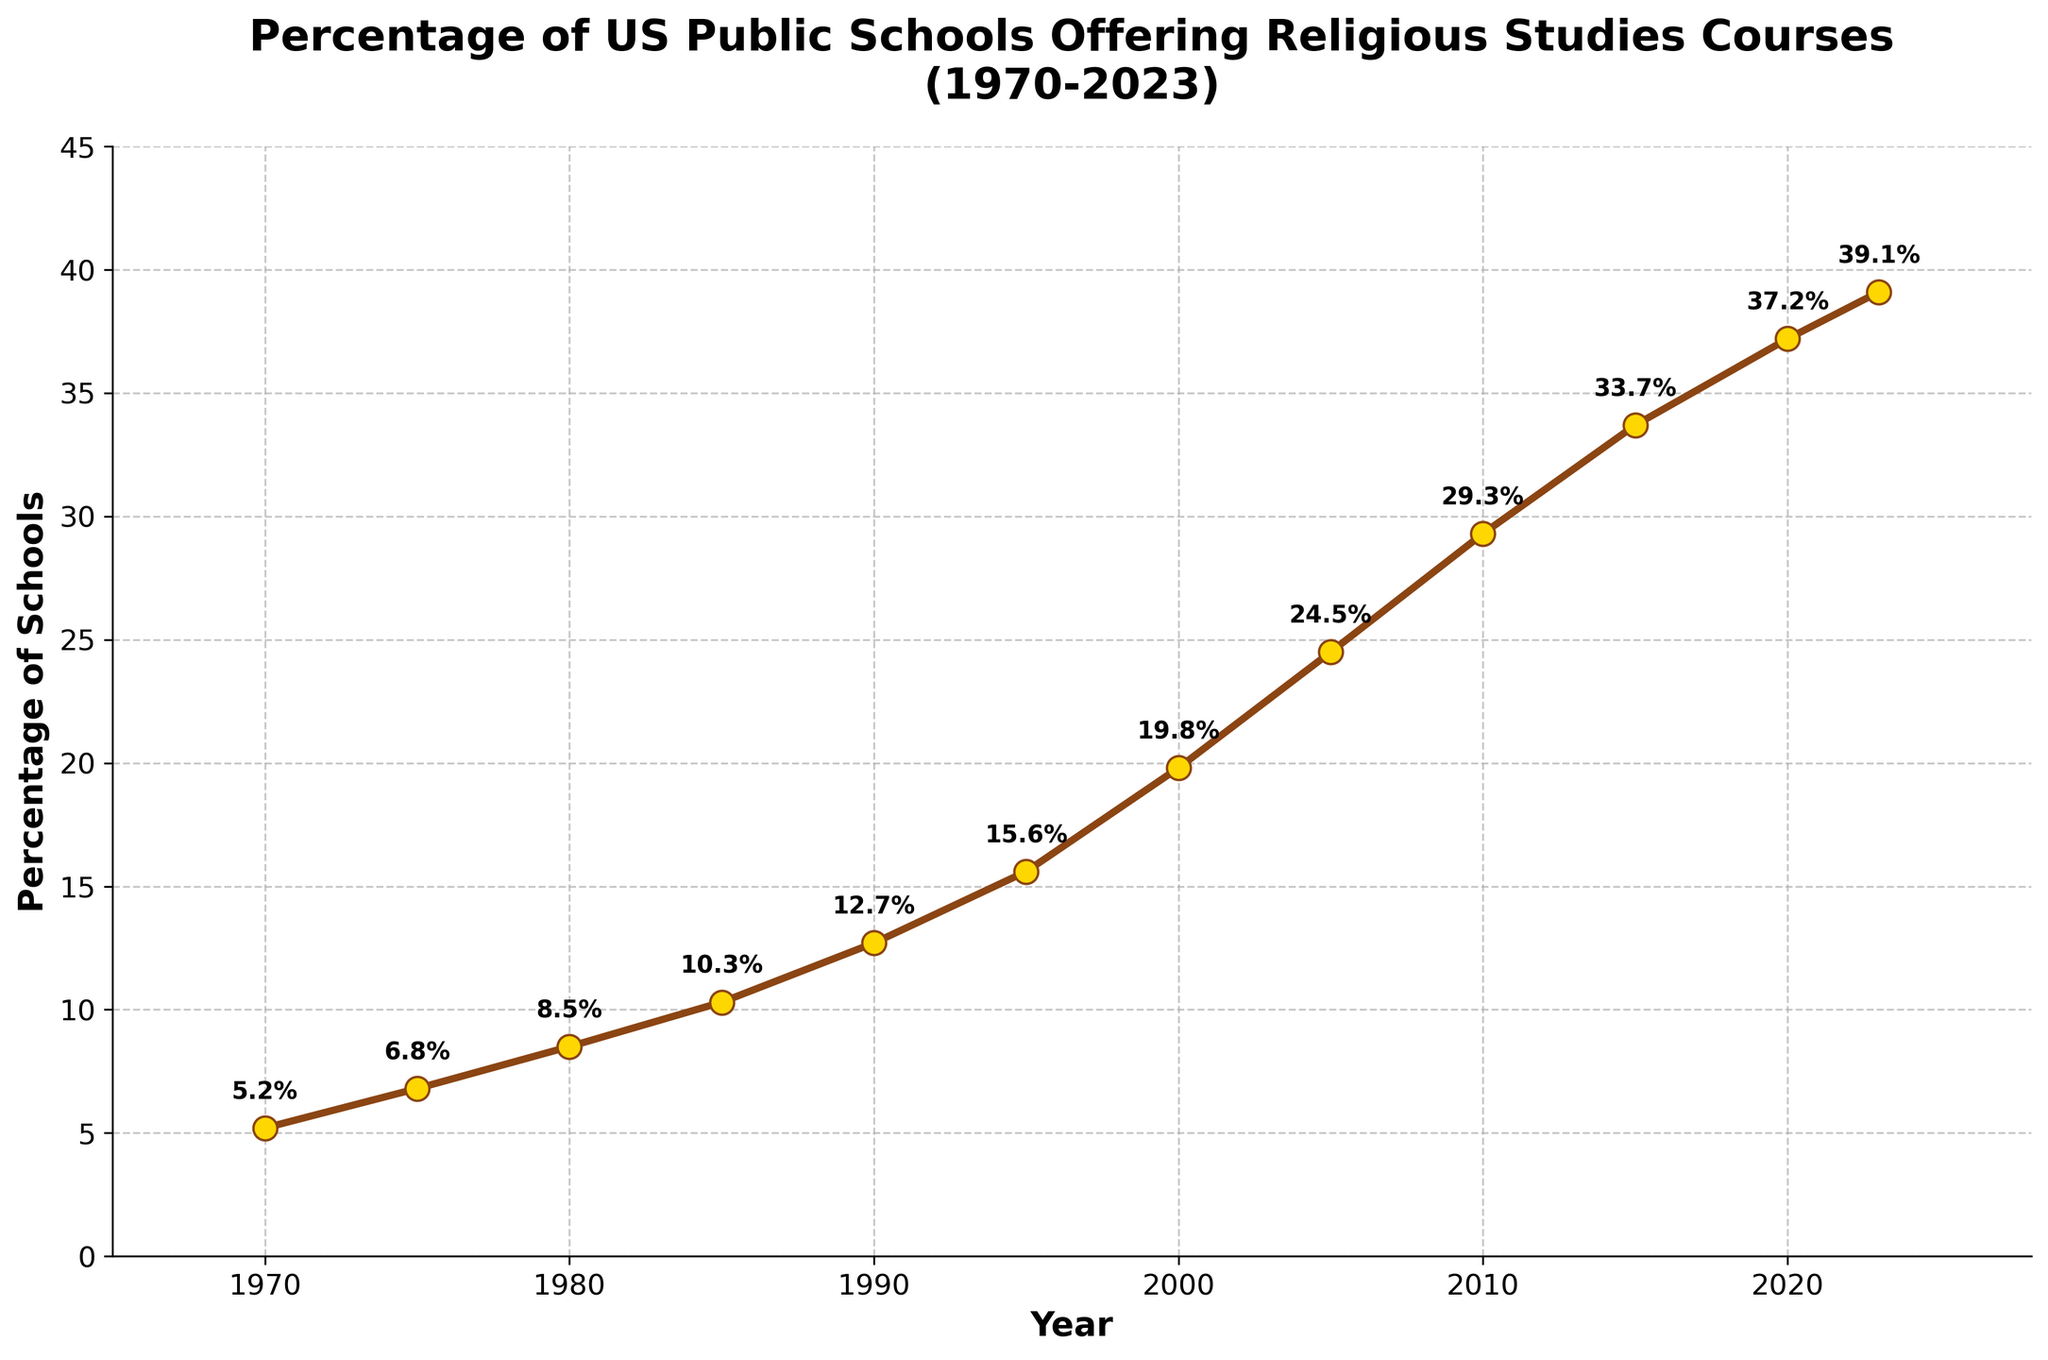What was the percentage increase in US public schools offering religious studies courses from 1970 to 2023? Subtract the percentage in 1970 from the percentage in 2023: 39.1% - 5.2% = 33.9%.
Answer: 33.9% In which decade did the percentage of US public schools offering religious studies courses increase the most? Calculate the increase for each decade: 1970s (6.8 - 5.2 = 1.6), 1980s (10.3 - 6.8 = 3.5), 1990s (15.6 - 10.3 = 5.3), 2000s (24.5 - 15.6 = 8.9), 2010s (33.7 - 24.5 = 9.2), and 2020s (39.1 - 33.7 = 5.4). The highest increase occurred in the 2010s.
Answer: 2010s Compare the percentage of schools offering religious studies courses in 1980 and 2000. What is the difference in percentage points? Subtract the percentage in 1980 from the percentage in 2000: 19.8% - 8.5% = 11.3%.
Answer: 11.3% What is the average percentage of schools offering religious studies courses in the first three decades (1970-2000)? Sum the percentages of the first three decades (5.2 + 6.8 + 8.5 + 10.3 + 12.7 + 15.6 + 19.8) which equals 78.9, then divide by the number of years (7): 78.9 / 7 = 11.27%.
Answer: 11.27% Which year marks the first time that more than 20% of US public schools offered religious studies courses? Review the percentages year by year and note that 2005 is the first year to exceed 20%, with a percentage of 24.5%.
Answer: 2005 When was the percentage of schools offering religious studies courses roughly double compared to 1975? Identify 1975's percentage (6.8%), double it (6.8 * 2 = 13.6), and find that the earliest year exceeding this was 1990 with 12.7%.
Answer: 1990 What is the rate of increase in the percentage of schools offering religious studies courses during the 21st century (2000-2023)? Calculate the difference between 2023 and 2000 percentages (39.1 - 19.8 = 19.3) and divide by the number of years (2023 - 2000 = 23): 19.3 / 23 ≈ 0.839%.
Answer: 0.839% Identify the year with the highest percentage increase compared to its preceding year. What is that increase? Calculate yearly increases and find the largest: 1975-1970 (1.6), 1980-1975 (1.7), 1985-1980 (1.8), 1990-1985 (2.4), 1995-1990 (2.9), 2000-1995 (4.2), 2005-2000 (4.7), 2010-2005 (4.8), 2015-2010 (4.4), 2020-2015 (3.5), 2023-2020 (1.9). The highest increase occurred from 2010 to 2015 (4.8%).
Answer: 4.8% What trend can be observed from the line chart in terms of the percentage of US public schools offering religious studies courses from 1970 to 2023? By looking at the line chart, it is evident that there is a steadily increasing trend in the percentage of schools offering religious studies courses over the years, with no major drops.
Answer: Increasing trend 